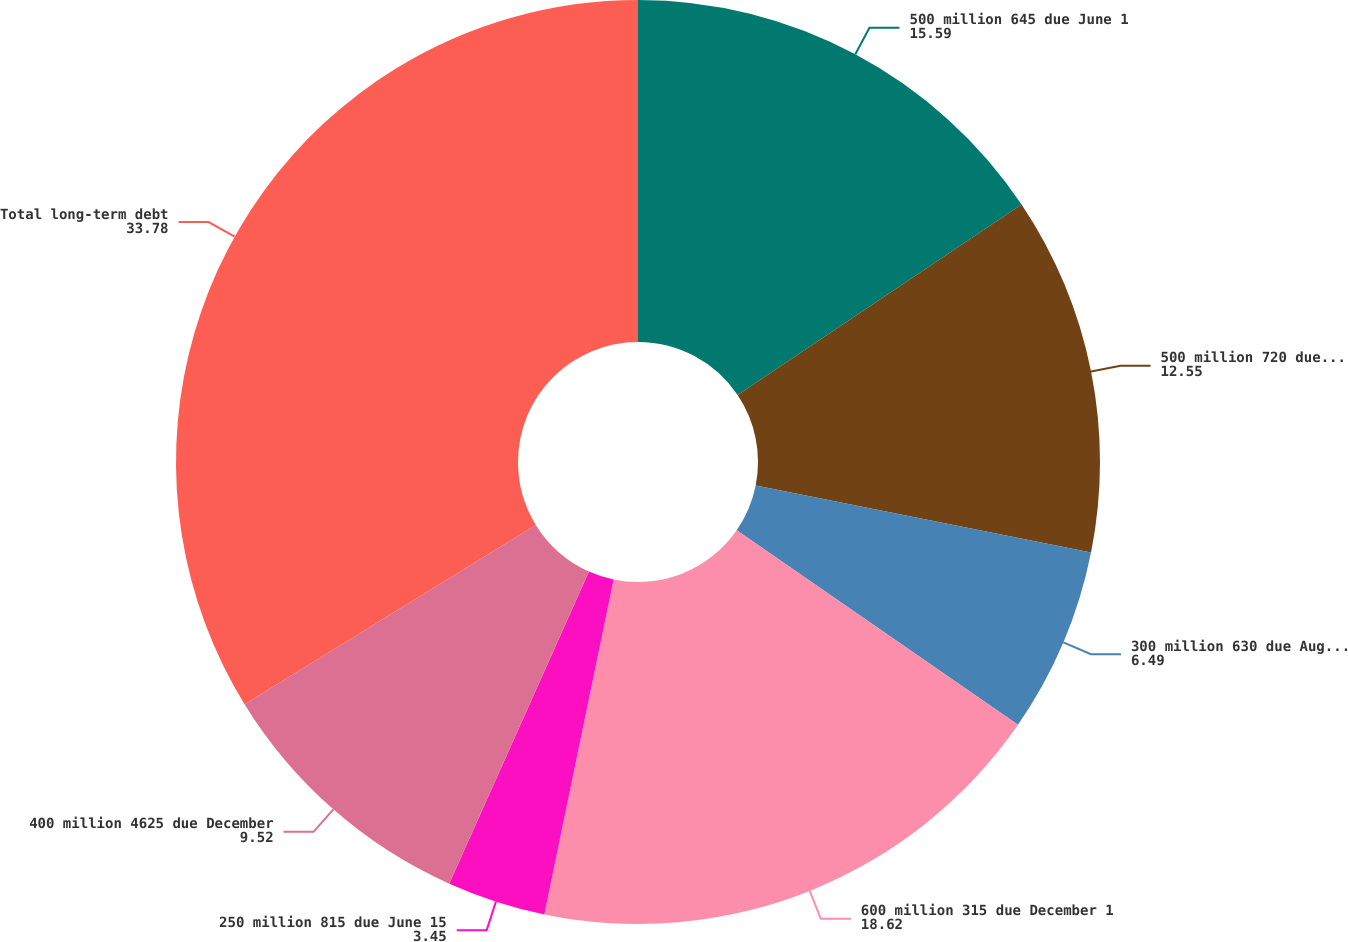<chart> <loc_0><loc_0><loc_500><loc_500><pie_chart><fcel>500 million 645 due June 1<fcel>500 million 720 due June 15<fcel>300 million 630 due August 1<fcel>600 million 315 due December 1<fcel>250 million 815 due June 15<fcel>400 million 4625 due December<fcel>Total long-term debt<nl><fcel>15.59%<fcel>12.55%<fcel>6.49%<fcel>18.62%<fcel>3.45%<fcel>9.52%<fcel>33.78%<nl></chart> 